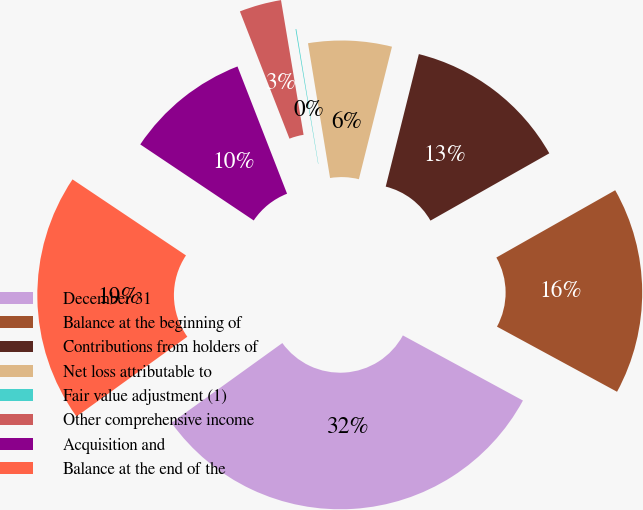<chart> <loc_0><loc_0><loc_500><loc_500><pie_chart><fcel>December 31<fcel>Balance at the beginning of<fcel>Contributions from holders of<fcel>Net loss attributable to<fcel>Fair value adjustment (1)<fcel>Other comprehensive income<fcel>Acquisition and<fcel>Balance at the end of the<nl><fcel>32.16%<fcel>16.11%<fcel>12.9%<fcel>6.48%<fcel>0.06%<fcel>3.27%<fcel>9.69%<fcel>19.32%<nl></chart> 